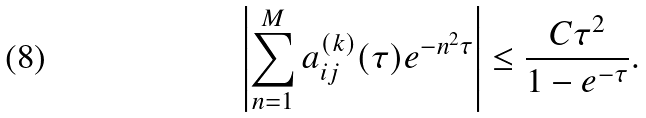<formula> <loc_0><loc_0><loc_500><loc_500>\left | \sum _ { n = 1 } ^ { M } a _ { i j } ^ { ( k ) } ( \tau ) e ^ { - n ^ { 2 } \tau } \right | \leq \frac { C \tau ^ { 2 } } { 1 - e ^ { - \tau } } .</formula> 